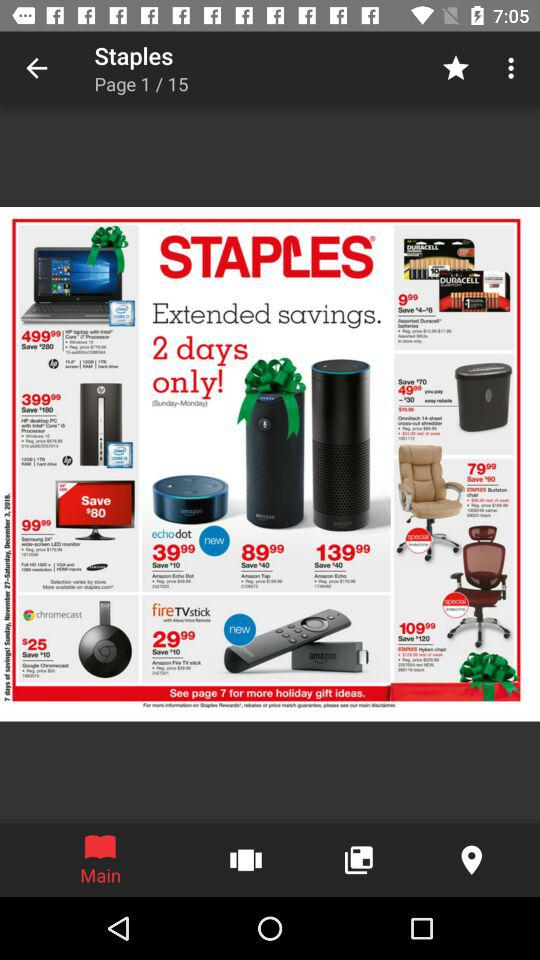Which tab is selected? The selected tab is "Main". 